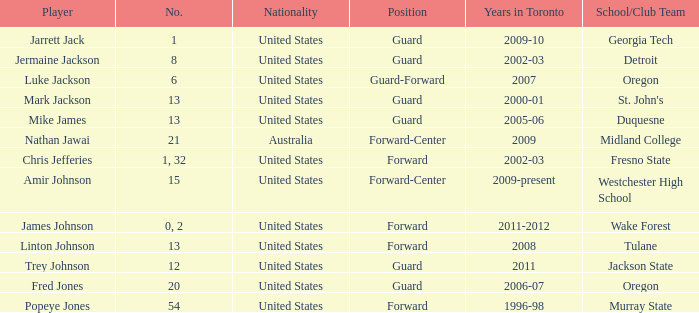What educational institution/organization squad does amir johnson belong to? Westchester High School. 